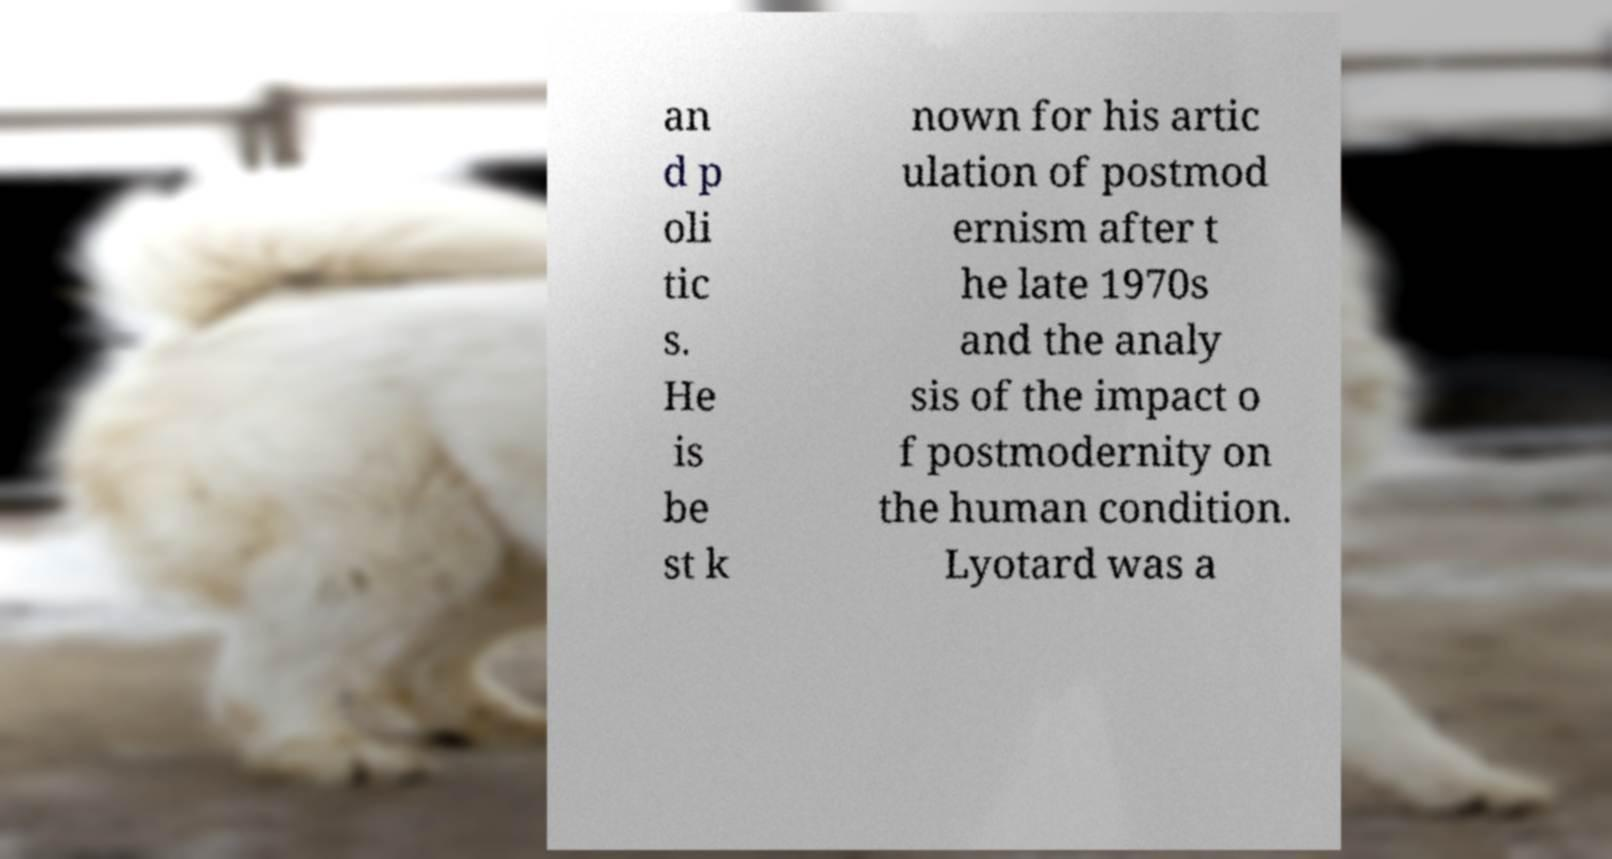What messages or text are displayed in this image? I need them in a readable, typed format. an d p oli tic s. He is be st k nown for his artic ulation of postmod ernism after t he late 1970s and the analy sis of the impact o f postmodernity on the human condition. Lyotard was a 